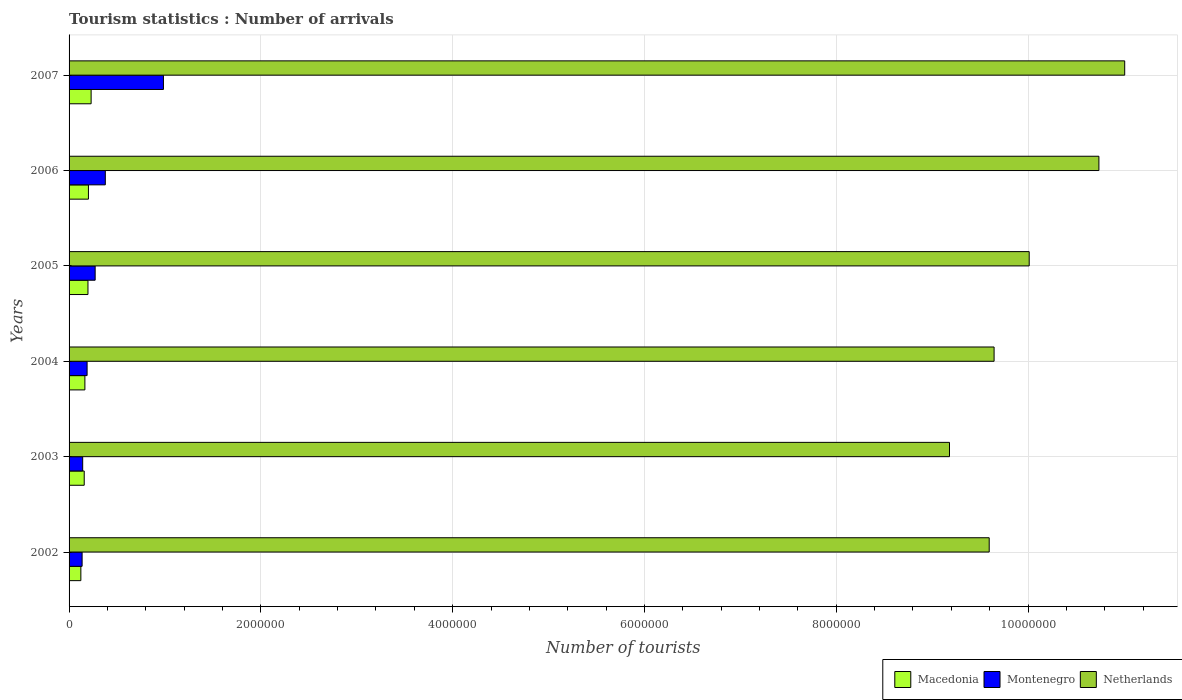Are the number of bars per tick equal to the number of legend labels?
Ensure brevity in your answer.  Yes. How many bars are there on the 4th tick from the bottom?
Provide a succinct answer. 3. In how many cases, is the number of bars for a given year not equal to the number of legend labels?
Provide a succinct answer. 0. What is the number of tourist arrivals in Macedonia in 2003?
Your answer should be compact. 1.58e+05. Across all years, what is the maximum number of tourist arrivals in Netherlands?
Make the answer very short. 1.10e+07. Across all years, what is the minimum number of tourist arrivals in Montenegro?
Your answer should be very brief. 1.36e+05. In which year was the number of tourist arrivals in Macedonia maximum?
Offer a terse response. 2007. In which year was the number of tourist arrivals in Macedonia minimum?
Provide a succinct answer. 2002. What is the total number of tourist arrivals in Macedonia in the graph?
Offer a terse response. 1.08e+06. What is the difference between the number of tourist arrivals in Montenegro in 2004 and that in 2007?
Offer a terse response. -7.96e+05. What is the difference between the number of tourist arrivals in Macedonia in 2005 and the number of tourist arrivals in Netherlands in 2007?
Make the answer very short. -1.08e+07. What is the average number of tourist arrivals in Netherlands per year?
Give a very brief answer. 1.00e+07. In the year 2006, what is the difference between the number of tourist arrivals in Montenegro and number of tourist arrivals in Netherlands?
Your answer should be compact. -1.04e+07. In how many years, is the number of tourist arrivals in Macedonia greater than 400000 ?
Offer a very short reply. 0. What is the ratio of the number of tourist arrivals in Montenegro in 2006 to that in 2007?
Provide a succinct answer. 0.38. Is the number of tourist arrivals in Macedonia in 2003 less than that in 2005?
Make the answer very short. Yes. Is the difference between the number of tourist arrivals in Montenegro in 2005 and 2007 greater than the difference between the number of tourist arrivals in Netherlands in 2005 and 2007?
Provide a short and direct response. Yes. What is the difference between the highest and the second highest number of tourist arrivals in Netherlands?
Your response must be concise. 2.69e+05. What is the difference between the highest and the lowest number of tourist arrivals in Macedonia?
Your answer should be compact. 1.07e+05. Is the sum of the number of tourist arrivals in Montenegro in 2006 and 2007 greater than the maximum number of tourist arrivals in Macedonia across all years?
Your answer should be very brief. Yes. What does the 2nd bar from the top in 2007 represents?
Give a very brief answer. Montenegro. What does the 2nd bar from the bottom in 2006 represents?
Make the answer very short. Montenegro. Are all the bars in the graph horizontal?
Your response must be concise. Yes. How many years are there in the graph?
Ensure brevity in your answer.  6. How are the legend labels stacked?
Give a very brief answer. Horizontal. What is the title of the graph?
Your answer should be compact. Tourism statistics : Number of arrivals. What is the label or title of the X-axis?
Keep it short and to the point. Number of tourists. What is the Number of tourists in Macedonia in 2002?
Keep it short and to the point. 1.23e+05. What is the Number of tourists of Montenegro in 2002?
Give a very brief answer. 1.36e+05. What is the Number of tourists in Netherlands in 2002?
Your answer should be very brief. 9.60e+06. What is the Number of tourists in Macedonia in 2003?
Offer a terse response. 1.58e+05. What is the Number of tourists in Montenegro in 2003?
Provide a succinct answer. 1.42e+05. What is the Number of tourists in Netherlands in 2003?
Offer a very short reply. 9.18e+06. What is the Number of tourists of Macedonia in 2004?
Your response must be concise. 1.65e+05. What is the Number of tourists of Montenegro in 2004?
Ensure brevity in your answer.  1.88e+05. What is the Number of tourists of Netherlands in 2004?
Provide a succinct answer. 9.65e+06. What is the Number of tourists in Macedonia in 2005?
Keep it short and to the point. 1.97e+05. What is the Number of tourists of Montenegro in 2005?
Provide a short and direct response. 2.72e+05. What is the Number of tourists of Netherlands in 2005?
Your response must be concise. 1.00e+07. What is the Number of tourists of Macedonia in 2006?
Your response must be concise. 2.02e+05. What is the Number of tourists in Montenegro in 2006?
Ensure brevity in your answer.  3.78e+05. What is the Number of tourists of Netherlands in 2006?
Provide a succinct answer. 1.07e+07. What is the Number of tourists of Montenegro in 2007?
Your response must be concise. 9.84e+05. What is the Number of tourists of Netherlands in 2007?
Provide a short and direct response. 1.10e+07. Across all years, what is the maximum Number of tourists in Montenegro?
Make the answer very short. 9.84e+05. Across all years, what is the maximum Number of tourists in Netherlands?
Provide a short and direct response. 1.10e+07. Across all years, what is the minimum Number of tourists in Macedonia?
Provide a succinct answer. 1.23e+05. Across all years, what is the minimum Number of tourists in Montenegro?
Provide a short and direct response. 1.36e+05. Across all years, what is the minimum Number of tourists of Netherlands?
Give a very brief answer. 9.18e+06. What is the total Number of tourists of Macedonia in the graph?
Make the answer very short. 1.08e+06. What is the total Number of tourists in Montenegro in the graph?
Ensure brevity in your answer.  2.10e+06. What is the total Number of tourists in Netherlands in the graph?
Your answer should be very brief. 6.02e+07. What is the difference between the Number of tourists in Macedonia in 2002 and that in 2003?
Your answer should be compact. -3.50e+04. What is the difference between the Number of tourists of Montenegro in 2002 and that in 2003?
Provide a short and direct response. -6000. What is the difference between the Number of tourists in Netherlands in 2002 and that in 2003?
Make the answer very short. 4.14e+05. What is the difference between the Number of tourists of Macedonia in 2002 and that in 2004?
Give a very brief answer. -4.20e+04. What is the difference between the Number of tourists of Montenegro in 2002 and that in 2004?
Provide a short and direct response. -5.20e+04. What is the difference between the Number of tourists in Netherlands in 2002 and that in 2004?
Your response must be concise. -5.10e+04. What is the difference between the Number of tourists in Macedonia in 2002 and that in 2005?
Offer a terse response. -7.40e+04. What is the difference between the Number of tourists of Montenegro in 2002 and that in 2005?
Provide a short and direct response. -1.36e+05. What is the difference between the Number of tourists in Netherlands in 2002 and that in 2005?
Ensure brevity in your answer.  -4.17e+05. What is the difference between the Number of tourists of Macedonia in 2002 and that in 2006?
Offer a terse response. -7.90e+04. What is the difference between the Number of tourists in Montenegro in 2002 and that in 2006?
Provide a short and direct response. -2.42e+05. What is the difference between the Number of tourists in Netherlands in 2002 and that in 2006?
Keep it short and to the point. -1.14e+06. What is the difference between the Number of tourists of Macedonia in 2002 and that in 2007?
Provide a succinct answer. -1.07e+05. What is the difference between the Number of tourists in Montenegro in 2002 and that in 2007?
Your answer should be very brief. -8.48e+05. What is the difference between the Number of tourists in Netherlands in 2002 and that in 2007?
Your answer should be very brief. -1.41e+06. What is the difference between the Number of tourists of Macedonia in 2003 and that in 2004?
Offer a terse response. -7000. What is the difference between the Number of tourists of Montenegro in 2003 and that in 2004?
Give a very brief answer. -4.60e+04. What is the difference between the Number of tourists in Netherlands in 2003 and that in 2004?
Ensure brevity in your answer.  -4.65e+05. What is the difference between the Number of tourists of Macedonia in 2003 and that in 2005?
Offer a terse response. -3.90e+04. What is the difference between the Number of tourists of Netherlands in 2003 and that in 2005?
Your response must be concise. -8.31e+05. What is the difference between the Number of tourists in Macedonia in 2003 and that in 2006?
Offer a very short reply. -4.40e+04. What is the difference between the Number of tourists in Montenegro in 2003 and that in 2006?
Your answer should be compact. -2.36e+05. What is the difference between the Number of tourists of Netherlands in 2003 and that in 2006?
Ensure brevity in your answer.  -1.56e+06. What is the difference between the Number of tourists of Macedonia in 2003 and that in 2007?
Keep it short and to the point. -7.20e+04. What is the difference between the Number of tourists in Montenegro in 2003 and that in 2007?
Provide a short and direct response. -8.42e+05. What is the difference between the Number of tourists of Netherlands in 2003 and that in 2007?
Your response must be concise. -1.83e+06. What is the difference between the Number of tourists of Macedonia in 2004 and that in 2005?
Keep it short and to the point. -3.20e+04. What is the difference between the Number of tourists in Montenegro in 2004 and that in 2005?
Your answer should be compact. -8.40e+04. What is the difference between the Number of tourists of Netherlands in 2004 and that in 2005?
Provide a succinct answer. -3.66e+05. What is the difference between the Number of tourists of Macedonia in 2004 and that in 2006?
Your response must be concise. -3.70e+04. What is the difference between the Number of tourists in Netherlands in 2004 and that in 2006?
Provide a succinct answer. -1.09e+06. What is the difference between the Number of tourists in Macedonia in 2004 and that in 2007?
Keep it short and to the point. -6.50e+04. What is the difference between the Number of tourists in Montenegro in 2004 and that in 2007?
Ensure brevity in your answer.  -7.96e+05. What is the difference between the Number of tourists in Netherlands in 2004 and that in 2007?
Ensure brevity in your answer.  -1.36e+06. What is the difference between the Number of tourists of Macedonia in 2005 and that in 2006?
Provide a short and direct response. -5000. What is the difference between the Number of tourists of Montenegro in 2005 and that in 2006?
Give a very brief answer. -1.06e+05. What is the difference between the Number of tourists in Netherlands in 2005 and that in 2006?
Provide a succinct answer. -7.27e+05. What is the difference between the Number of tourists of Macedonia in 2005 and that in 2007?
Your response must be concise. -3.30e+04. What is the difference between the Number of tourists of Montenegro in 2005 and that in 2007?
Your response must be concise. -7.12e+05. What is the difference between the Number of tourists in Netherlands in 2005 and that in 2007?
Offer a terse response. -9.96e+05. What is the difference between the Number of tourists in Macedonia in 2006 and that in 2007?
Your answer should be compact. -2.80e+04. What is the difference between the Number of tourists of Montenegro in 2006 and that in 2007?
Provide a short and direct response. -6.06e+05. What is the difference between the Number of tourists in Netherlands in 2006 and that in 2007?
Ensure brevity in your answer.  -2.69e+05. What is the difference between the Number of tourists in Macedonia in 2002 and the Number of tourists in Montenegro in 2003?
Give a very brief answer. -1.90e+04. What is the difference between the Number of tourists in Macedonia in 2002 and the Number of tourists in Netherlands in 2003?
Ensure brevity in your answer.  -9.06e+06. What is the difference between the Number of tourists in Montenegro in 2002 and the Number of tourists in Netherlands in 2003?
Offer a terse response. -9.04e+06. What is the difference between the Number of tourists in Macedonia in 2002 and the Number of tourists in Montenegro in 2004?
Your answer should be compact. -6.50e+04. What is the difference between the Number of tourists of Macedonia in 2002 and the Number of tourists of Netherlands in 2004?
Provide a succinct answer. -9.52e+06. What is the difference between the Number of tourists in Montenegro in 2002 and the Number of tourists in Netherlands in 2004?
Keep it short and to the point. -9.51e+06. What is the difference between the Number of tourists in Macedonia in 2002 and the Number of tourists in Montenegro in 2005?
Your response must be concise. -1.49e+05. What is the difference between the Number of tourists in Macedonia in 2002 and the Number of tourists in Netherlands in 2005?
Make the answer very short. -9.89e+06. What is the difference between the Number of tourists in Montenegro in 2002 and the Number of tourists in Netherlands in 2005?
Provide a succinct answer. -9.88e+06. What is the difference between the Number of tourists in Macedonia in 2002 and the Number of tourists in Montenegro in 2006?
Provide a succinct answer. -2.55e+05. What is the difference between the Number of tourists in Macedonia in 2002 and the Number of tourists in Netherlands in 2006?
Keep it short and to the point. -1.06e+07. What is the difference between the Number of tourists of Montenegro in 2002 and the Number of tourists of Netherlands in 2006?
Make the answer very short. -1.06e+07. What is the difference between the Number of tourists of Macedonia in 2002 and the Number of tourists of Montenegro in 2007?
Offer a terse response. -8.61e+05. What is the difference between the Number of tourists of Macedonia in 2002 and the Number of tourists of Netherlands in 2007?
Provide a short and direct response. -1.09e+07. What is the difference between the Number of tourists in Montenegro in 2002 and the Number of tourists in Netherlands in 2007?
Give a very brief answer. -1.09e+07. What is the difference between the Number of tourists of Macedonia in 2003 and the Number of tourists of Montenegro in 2004?
Ensure brevity in your answer.  -3.00e+04. What is the difference between the Number of tourists in Macedonia in 2003 and the Number of tourists in Netherlands in 2004?
Ensure brevity in your answer.  -9.49e+06. What is the difference between the Number of tourists of Montenegro in 2003 and the Number of tourists of Netherlands in 2004?
Your answer should be very brief. -9.50e+06. What is the difference between the Number of tourists of Macedonia in 2003 and the Number of tourists of Montenegro in 2005?
Your response must be concise. -1.14e+05. What is the difference between the Number of tourists of Macedonia in 2003 and the Number of tourists of Netherlands in 2005?
Keep it short and to the point. -9.85e+06. What is the difference between the Number of tourists in Montenegro in 2003 and the Number of tourists in Netherlands in 2005?
Provide a short and direct response. -9.87e+06. What is the difference between the Number of tourists of Macedonia in 2003 and the Number of tourists of Montenegro in 2006?
Your response must be concise. -2.20e+05. What is the difference between the Number of tourists in Macedonia in 2003 and the Number of tourists in Netherlands in 2006?
Give a very brief answer. -1.06e+07. What is the difference between the Number of tourists in Montenegro in 2003 and the Number of tourists in Netherlands in 2006?
Make the answer very short. -1.06e+07. What is the difference between the Number of tourists in Macedonia in 2003 and the Number of tourists in Montenegro in 2007?
Your response must be concise. -8.26e+05. What is the difference between the Number of tourists in Macedonia in 2003 and the Number of tourists in Netherlands in 2007?
Offer a very short reply. -1.08e+07. What is the difference between the Number of tourists of Montenegro in 2003 and the Number of tourists of Netherlands in 2007?
Your answer should be compact. -1.09e+07. What is the difference between the Number of tourists in Macedonia in 2004 and the Number of tourists in Montenegro in 2005?
Ensure brevity in your answer.  -1.07e+05. What is the difference between the Number of tourists in Macedonia in 2004 and the Number of tourists in Netherlands in 2005?
Your answer should be compact. -9.85e+06. What is the difference between the Number of tourists in Montenegro in 2004 and the Number of tourists in Netherlands in 2005?
Provide a short and direct response. -9.82e+06. What is the difference between the Number of tourists of Macedonia in 2004 and the Number of tourists of Montenegro in 2006?
Provide a succinct answer. -2.13e+05. What is the difference between the Number of tourists in Macedonia in 2004 and the Number of tourists in Netherlands in 2006?
Provide a short and direct response. -1.06e+07. What is the difference between the Number of tourists in Montenegro in 2004 and the Number of tourists in Netherlands in 2006?
Your response must be concise. -1.06e+07. What is the difference between the Number of tourists of Macedonia in 2004 and the Number of tourists of Montenegro in 2007?
Your answer should be compact. -8.19e+05. What is the difference between the Number of tourists of Macedonia in 2004 and the Number of tourists of Netherlands in 2007?
Your answer should be very brief. -1.08e+07. What is the difference between the Number of tourists in Montenegro in 2004 and the Number of tourists in Netherlands in 2007?
Give a very brief answer. -1.08e+07. What is the difference between the Number of tourists in Macedonia in 2005 and the Number of tourists in Montenegro in 2006?
Provide a succinct answer. -1.81e+05. What is the difference between the Number of tourists in Macedonia in 2005 and the Number of tourists in Netherlands in 2006?
Your answer should be very brief. -1.05e+07. What is the difference between the Number of tourists in Montenegro in 2005 and the Number of tourists in Netherlands in 2006?
Provide a succinct answer. -1.05e+07. What is the difference between the Number of tourists of Macedonia in 2005 and the Number of tourists of Montenegro in 2007?
Offer a terse response. -7.87e+05. What is the difference between the Number of tourists of Macedonia in 2005 and the Number of tourists of Netherlands in 2007?
Your response must be concise. -1.08e+07. What is the difference between the Number of tourists in Montenegro in 2005 and the Number of tourists in Netherlands in 2007?
Your answer should be very brief. -1.07e+07. What is the difference between the Number of tourists in Macedonia in 2006 and the Number of tourists in Montenegro in 2007?
Offer a very short reply. -7.82e+05. What is the difference between the Number of tourists of Macedonia in 2006 and the Number of tourists of Netherlands in 2007?
Keep it short and to the point. -1.08e+07. What is the difference between the Number of tourists of Montenegro in 2006 and the Number of tourists of Netherlands in 2007?
Keep it short and to the point. -1.06e+07. What is the average Number of tourists in Macedonia per year?
Keep it short and to the point. 1.79e+05. What is the average Number of tourists in Netherlands per year?
Your response must be concise. 1.00e+07. In the year 2002, what is the difference between the Number of tourists of Macedonia and Number of tourists of Montenegro?
Offer a very short reply. -1.30e+04. In the year 2002, what is the difference between the Number of tourists in Macedonia and Number of tourists in Netherlands?
Keep it short and to the point. -9.47e+06. In the year 2002, what is the difference between the Number of tourists in Montenegro and Number of tourists in Netherlands?
Your response must be concise. -9.46e+06. In the year 2003, what is the difference between the Number of tourists in Macedonia and Number of tourists in Montenegro?
Make the answer very short. 1.60e+04. In the year 2003, what is the difference between the Number of tourists of Macedonia and Number of tourists of Netherlands?
Your answer should be very brief. -9.02e+06. In the year 2003, what is the difference between the Number of tourists in Montenegro and Number of tourists in Netherlands?
Offer a terse response. -9.04e+06. In the year 2004, what is the difference between the Number of tourists of Macedonia and Number of tourists of Montenegro?
Offer a terse response. -2.30e+04. In the year 2004, what is the difference between the Number of tourists of Macedonia and Number of tourists of Netherlands?
Offer a very short reply. -9.48e+06. In the year 2004, what is the difference between the Number of tourists in Montenegro and Number of tourists in Netherlands?
Your answer should be compact. -9.46e+06. In the year 2005, what is the difference between the Number of tourists in Macedonia and Number of tourists in Montenegro?
Provide a short and direct response. -7.50e+04. In the year 2005, what is the difference between the Number of tourists of Macedonia and Number of tourists of Netherlands?
Offer a very short reply. -9.82e+06. In the year 2005, what is the difference between the Number of tourists in Montenegro and Number of tourists in Netherlands?
Your answer should be very brief. -9.74e+06. In the year 2006, what is the difference between the Number of tourists in Macedonia and Number of tourists in Montenegro?
Give a very brief answer. -1.76e+05. In the year 2006, what is the difference between the Number of tourists in Macedonia and Number of tourists in Netherlands?
Offer a terse response. -1.05e+07. In the year 2006, what is the difference between the Number of tourists in Montenegro and Number of tourists in Netherlands?
Your answer should be compact. -1.04e+07. In the year 2007, what is the difference between the Number of tourists of Macedonia and Number of tourists of Montenegro?
Your answer should be very brief. -7.54e+05. In the year 2007, what is the difference between the Number of tourists in Macedonia and Number of tourists in Netherlands?
Offer a terse response. -1.08e+07. In the year 2007, what is the difference between the Number of tourists in Montenegro and Number of tourists in Netherlands?
Provide a succinct answer. -1.00e+07. What is the ratio of the Number of tourists of Macedonia in 2002 to that in 2003?
Provide a short and direct response. 0.78. What is the ratio of the Number of tourists of Montenegro in 2002 to that in 2003?
Offer a terse response. 0.96. What is the ratio of the Number of tourists of Netherlands in 2002 to that in 2003?
Offer a terse response. 1.05. What is the ratio of the Number of tourists in Macedonia in 2002 to that in 2004?
Ensure brevity in your answer.  0.75. What is the ratio of the Number of tourists in Montenegro in 2002 to that in 2004?
Ensure brevity in your answer.  0.72. What is the ratio of the Number of tourists in Netherlands in 2002 to that in 2004?
Make the answer very short. 0.99. What is the ratio of the Number of tourists of Macedonia in 2002 to that in 2005?
Make the answer very short. 0.62. What is the ratio of the Number of tourists of Montenegro in 2002 to that in 2005?
Your response must be concise. 0.5. What is the ratio of the Number of tourists in Netherlands in 2002 to that in 2005?
Offer a very short reply. 0.96. What is the ratio of the Number of tourists of Macedonia in 2002 to that in 2006?
Provide a succinct answer. 0.61. What is the ratio of the Number of tourists of Montenegro in 2002 to that in 2006?
Offer a very short reply. 0.36. What is the ratio of the Number of tourists of Netherlands in 2002 to that in 2006?
Your answer should be compact. 0.89. What is the ratio of the Number of tourists of Macedonia in 2002 to that in 2007?
Make the answer very short. 0.53. What is the ratio of the Number of tourists in Montenegro in 2002 to that in 2007?
Make the answer very short. 0.14. What is the ratio of the Number of tourists in Netherlands in 2002 to that in 2007?
Keep it short and to the point. 0.87. What is the ratio of the Number of tourists in Macedonia in 2003 to that in 2004?
Give a very brief answer. 0.96. What is the ratio of the Number of tourists in Montenegro in 2003 to that in 2004?
Your answer should be compact. 0.76. What is the ratio of the Number of tourists in Netherlands in 2003 to that in 2004?
Your answer should be very brief. 0.95. What is the ratio of the Number of tourists in Macedonia in 2003 to that in 2005?
Offer a very short reply. 0.8. What is the ratio of the Number of tourists in Montenegro in 2003 to that in 2005?
Ensure brevity in your answer.  0.52. What is the ratio of the Number of tourists of Netherlands in 2003 to that in 2005?
Your response must be concise. 0.92. What is the ratio of the Number of tourists in Macedonia in 2003 to that in 2006?
Offer a terse response. 0.78. What is the ratio of the Number of tourists of Montenegro in 2003 to that in 2006?
Your answer should be compact. 0.38. What is the ratio of the Number of tourists in Netherlands in 2003 to that in 2006?
Provide a succinct answer. 0.85. What is the ratio of the Number of tourists of Macedonia in 2003 to that in 2007?
Offer a very short reply. 0.69. What is the ratio of the Number of tourists of Montenegro in 2003 to that in 2007?
Provide a short and direct response. 0.14. What is the ratio of the Number of tourists of Netherlands in 2003 to that in 2007?
Your response must be concise. 0.83. What is the ratio of the Number of tourists in Macedonia in 2004 to that in 2005?
Provide a short and direct response. 0.84. What is the ratio of the Number of tourists of Montenegro in 2004 to that in 2005?
Keep it short and to the point. 0.69. What is the ratio of the Number of tourists of Netherlands in 2004 to that in 2005?
Keep it short and to the point. 0.96. What is the ratio of the Number of tourists of Macedonia in 2004 to that in 2006?
Offer a very short reply. 0.82. What is the ratio of the Number of tourists in Montenegro in 2004 to that in 2006?
Your answer should be compact. 0.5. What is the ratio of the Number of tourists of Netherlands in 2004 to that in 2006?
Provide a short and direct response. 0.9. What is the ratio of the Number of tourists of Macedonia in 2004 to that in 2007?
Your answer should be compact. 0.72. What is the ratio of the Number of tourists in Montenegro in 2004 to that in 2007?
Ensure brevity in your answer.  0.19. What is the ratio of the Number of tourists of Netherlands in 2004 to that in 2007?
Your answer should be compact. 0.88. What is the ratio of the Number of tourists in Macedonia in 2005 to that in 2006?
Ensure brevity in your answer.  0.98. What is the ratio of the Number of tourists of Montenegro in 2005 to that in 2006?
Your answer should be compact. 0.72. What is the ratio of the Number of tourists of Netherlands in 2005 to that in 2006?
Your answer should be very brief. 0.93. What is the ratio of the Number of tourists of Macedonia in 2005 to that in 2007?
Your response must be concise. 0.86. What is the ratio of the Number of tourists in Montenegro in 2005 to that in 2007?
Make the answer very short. 0.28. What is the ratio of the Number of tourists in Netherlands in 2005 to that in 2007?
Provide a short and direct response. 0.91. What is the ratio of the Number of tourists of Macedonia in 2006 to that in 2007?
Provide a succinct answer. 0.88. What is the ratio of the Number of tourists of Montenegro in 2006 to that in 2007?
Provide a short and direct response. 0.38. What is the ratio of the Number of tourists of Netherlands in 2006 to that in 2007?
Provide a succinct answer. 0.98. What is the difference between the highest and the second highest Number of tourists in Macedonia?
Make the answer very short. 2.80e+04. What is the difference between the highest and the second highest Number of tourists of Montenegro?
Provide a succinct answer. 6.06e+05. What is the difference between the highest and the second highest Number of tourists of Netherlands?
Keep it short and to the point. 2.69e+05. What is the difference between the highest and the lowest Number of tourists in Macedonia?
Give a very brief answer. 1.07e+05. What is the difference between the highest and the lowest Number of tourists in Montenegro?
Provide a short and direct response. 8.48e+05. What is the difference between the highest and the lowest Number of tourists in Netherlands?
Give a very brief answer. 1.83e+06. 